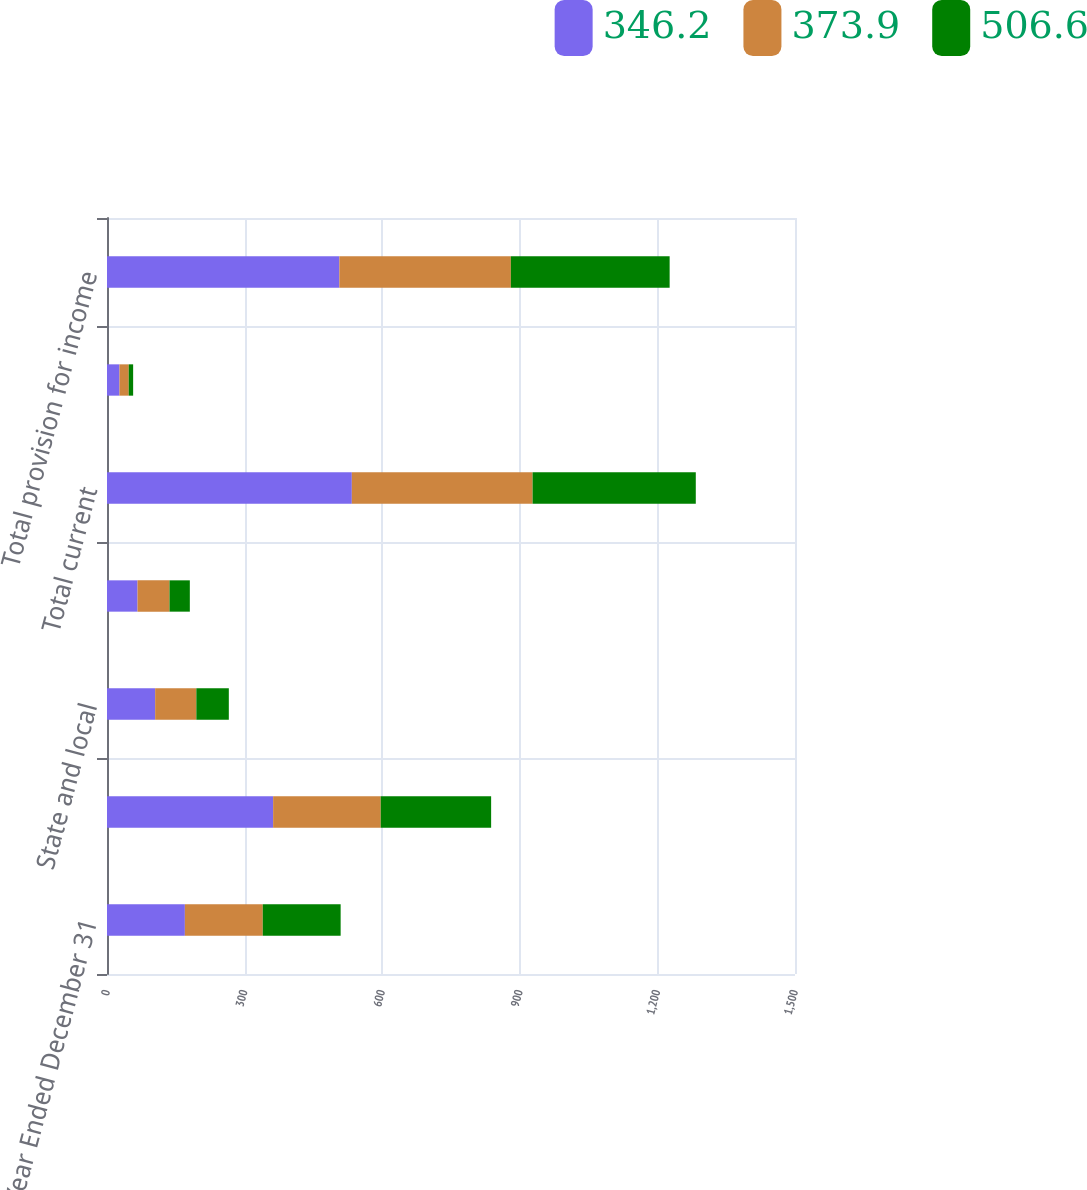Convert chart. <chart><loc_0><loc_0><loc_500><loc_500><stacked_bar_chart><ecel><fcel>Year Ended December 31<fcel>Federal<fcel>State and local<fcel>Non-US<fcel>Total current<fcel>Total deferred<fcel>Total provision for income<nl><fcel>346.2<fcel>169.8<fcel>362.2<fcel>105<fcel>66.6<fcel>533.8<fcel>27.2<fcel>506.6<nl><fcel>373.9<fcel>169.8<fcel>234.6<fcel>89.8<fcel>69.7<fcel>394.1<fcel>20.2<fcel>373.9<nl><fcel>506.6<fcel>169.8<fcel>240.7<fcel>70.8<fcel>44.3<fcel>355.8<fcel>9.6<fcel>346.2<nl></chart> 